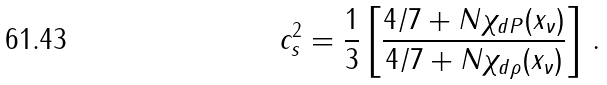Convert formula to latex. <formula><loc_0><loc_0><loc_500><loc_500>c _ { s } ^ { 2 } = \frac { 1 } { 3 } \left [ \frac { 4 / 7 + N \chi _ { d P } ( x _ { \nu } ) } { 4 / 7 + N \chi _ { d \rho } ( x _ { \nu } ) } \right ] \, .</formula> 